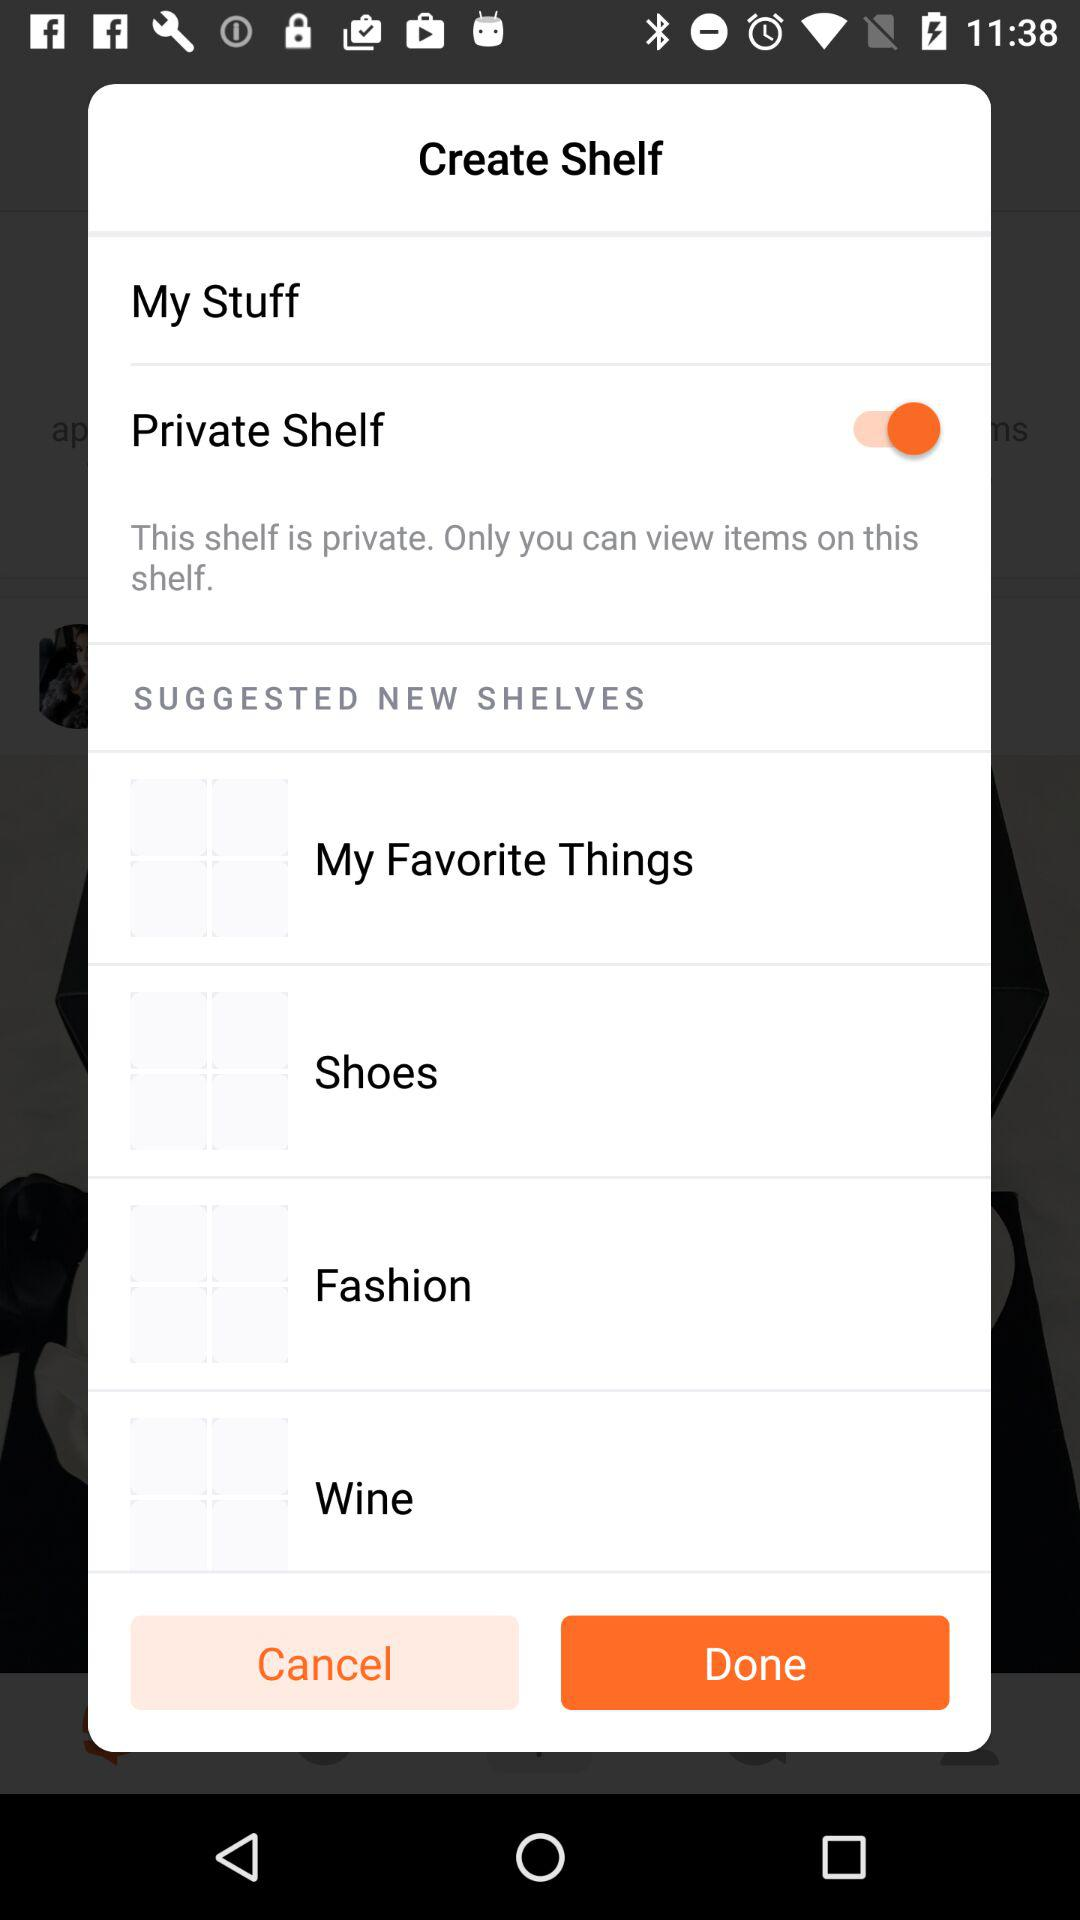What is the status of the private shelf? The status is "on". 